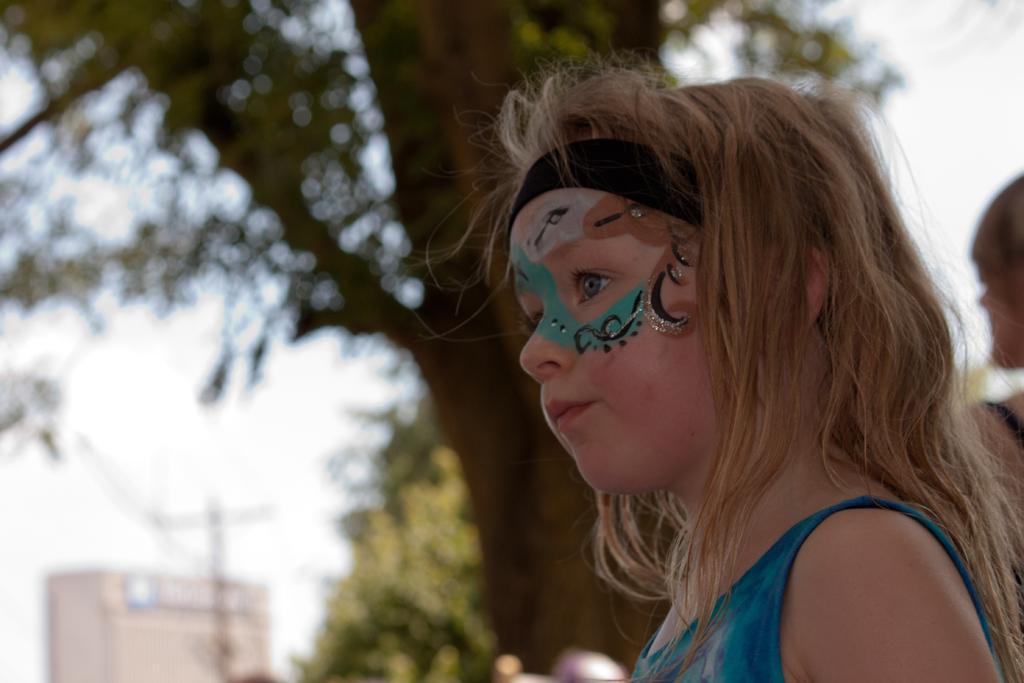Please provide a concise description of this image. In this picture we can see a girl with a painting on her face, trees, building and a person and in the background we can see the sky. 